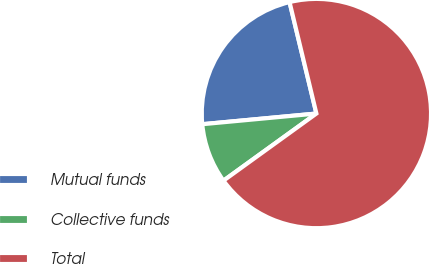<chart> <loc_0><loc_0><loc_500><loc_500><pie_chart><fcel>Mutual funds<fcel>Collective funds<fcel>Total<nl><fcel>22.72%<fcel>8.47%<fcel>68.81%<nl></chart> 